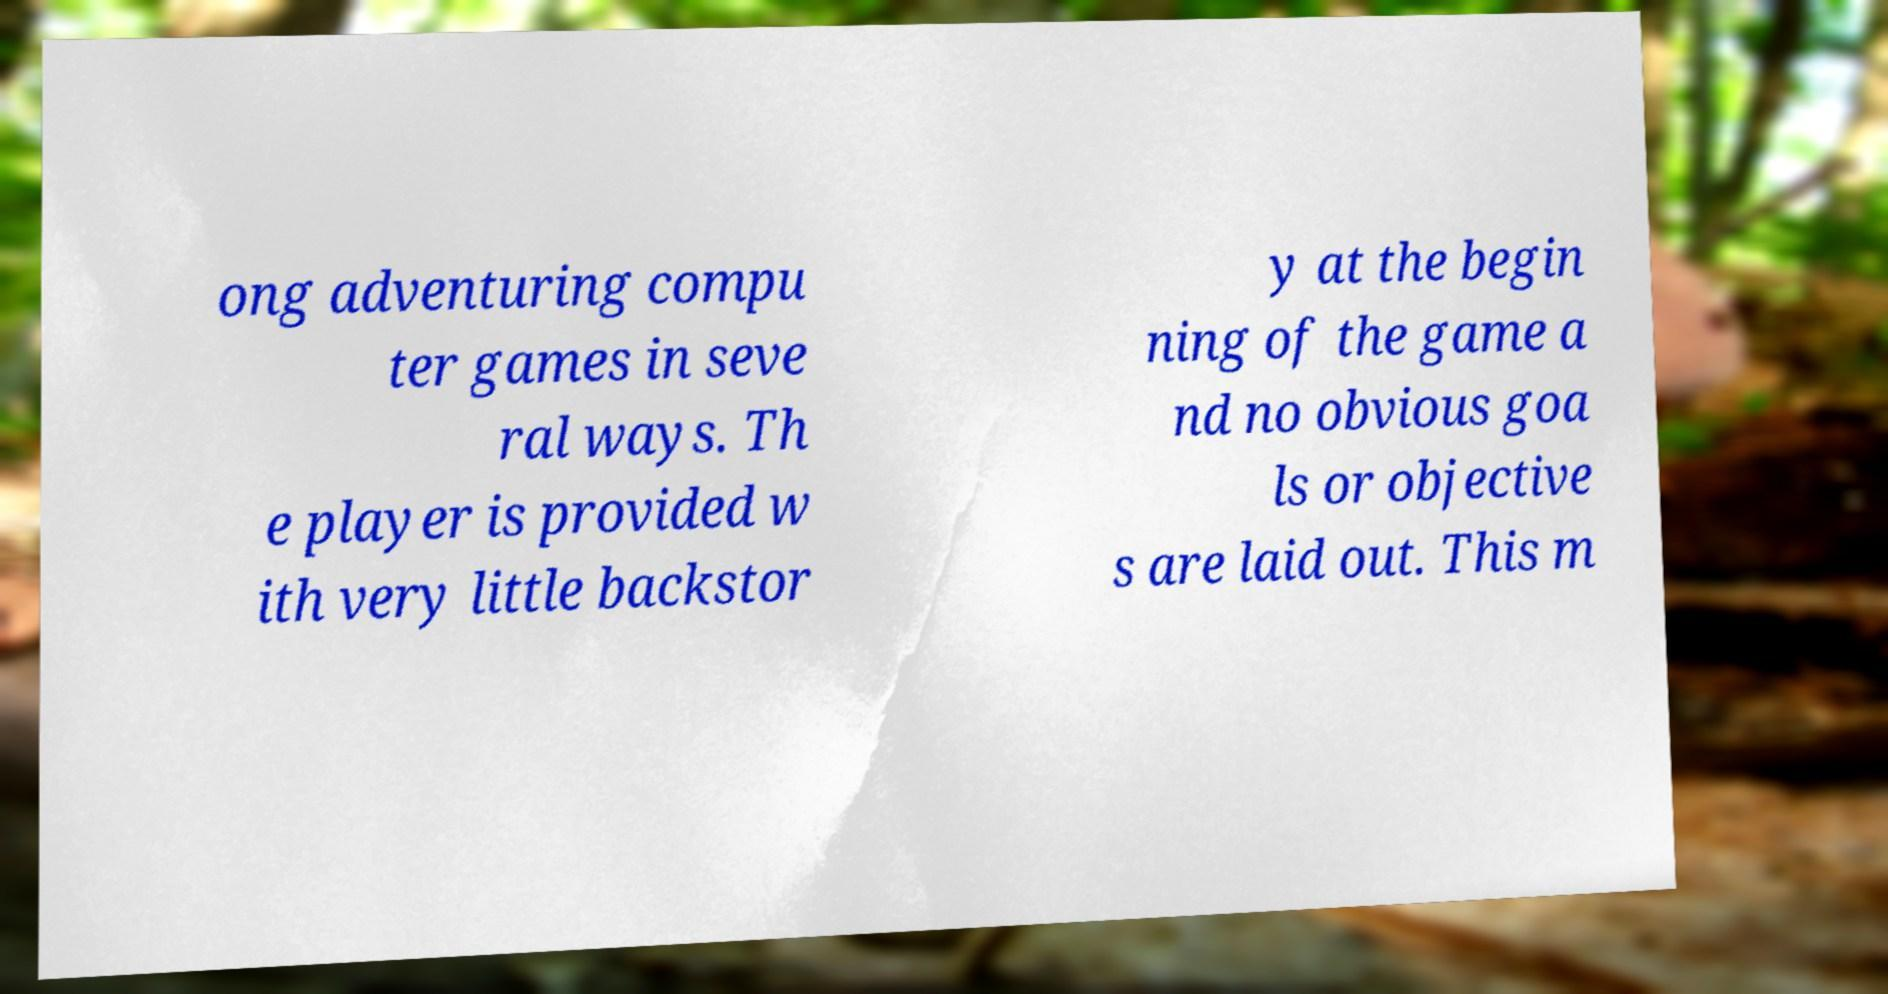What messages or text are displayed in this image? I need them in a readable, typed format. ong adventuring compu ter games in seve ral ways. Th e player is provided w ith very little backstor y at the begin ning of the game a nd no obvious goa ls or objective s are laid out. This m 